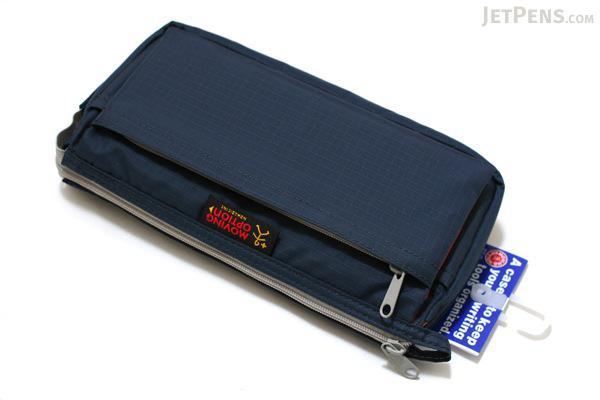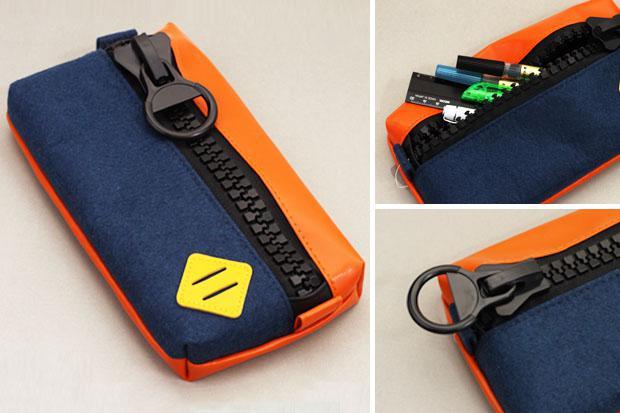The first image is the image on the left, the second image is the image on the right. Given the left and right images, does the statement "The left image shows exactly one case." hold true? Answer yes or no. Yes. 